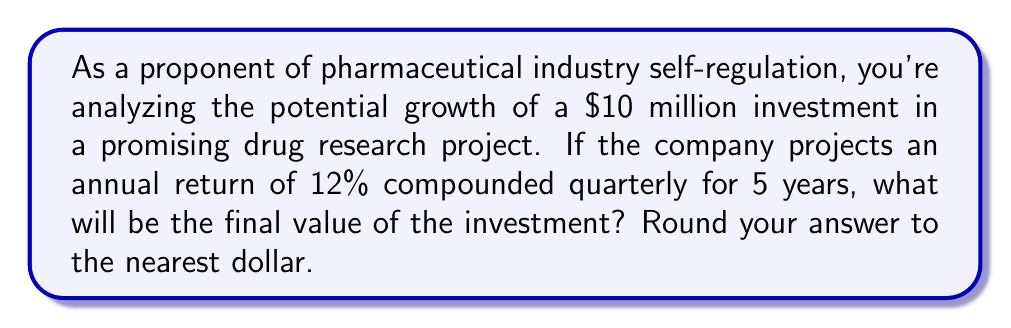What is the answer to this math problem? Let's approach this step-by-step using the compound interest formula:

$$A = P(1 + \frac{r}{n})^{nt}$$

Where:
$A$ = Final amount
$P$ = Principal (initial investment)
$r$ = Annual interest rate (in decimal form)
$n$ = Number of times interest is compounded per year
$t$ = Number of years

Given:
$P = \$10,000,000$
$r = 12\% = 0.12$
$n = 4$ (compounded quarterly)
$t = 5$ years

Let's substitute these values into the formula:

$$A = 10,000,000(1 + \frac{0.12}{4})^{4(5)}$$

$$A = 10,000,000(1 + 0.03)^{20}$$

$$A = 10,000,000(1.03)^{20}$$

Using a calculator or computer:

$$A = 10,000,000 * 1.806111385$$

$$A = 18,061,113.85$$

Rounding to the nearest dollar:

$$A = \$18,061,114$$

This demonstrates the significant growth potential in pharmaceutical investments without government intervention, supporting the idea of industry self-regulation.
Answer: $18,061,114 